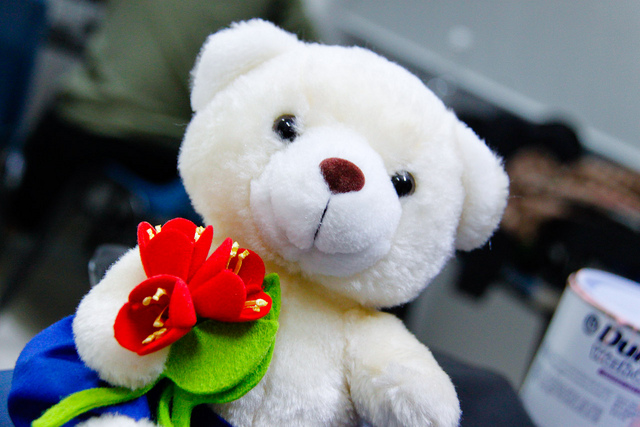<image>What is the teddy bear made of? I don't know what the teddy bear is made from. It could be made of cotton, fur, polyester, fake fur or acrylic. What is the teddy bear made of? I don't know what the teddy bear is made of. It can be fur, fabric, polyester, cotton, or acrylic. 